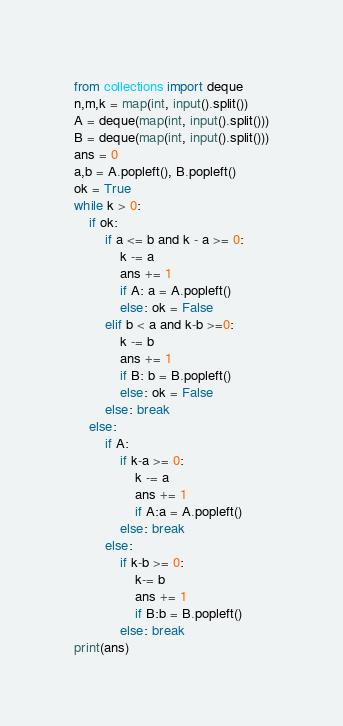<code> <loc_0><loc_0><loc_500><loc_500><_Python_>from collections import deque
n,m,k = map(int, input().split())
A = deque(map(int, input().split()))
B = deque(map(int, input().split()))
ans = 0
a,b = A.popleft(), B.popleft()
ok = True
while k > 0:
    if ok:
        if a <= b and k - a >= 0:
            k -= a
            ans += 1
            if A: a = A.popleft()
            else: ok = False
        elif b < a and k-b >=0:
            k -= b
            ans += 1
            if B: b = B.popleft()
            else: ok = False
        else: break
    else:
        if A:
            if k-a >= 0:
                k -= a
                ans += 1
                if A:a = A.popleft()
            else: break
        else:
            if k-b >= 0:
                k-= b
                ans += 1
                if B:b = B.popleft()
            else: break
print(ans)</code> 